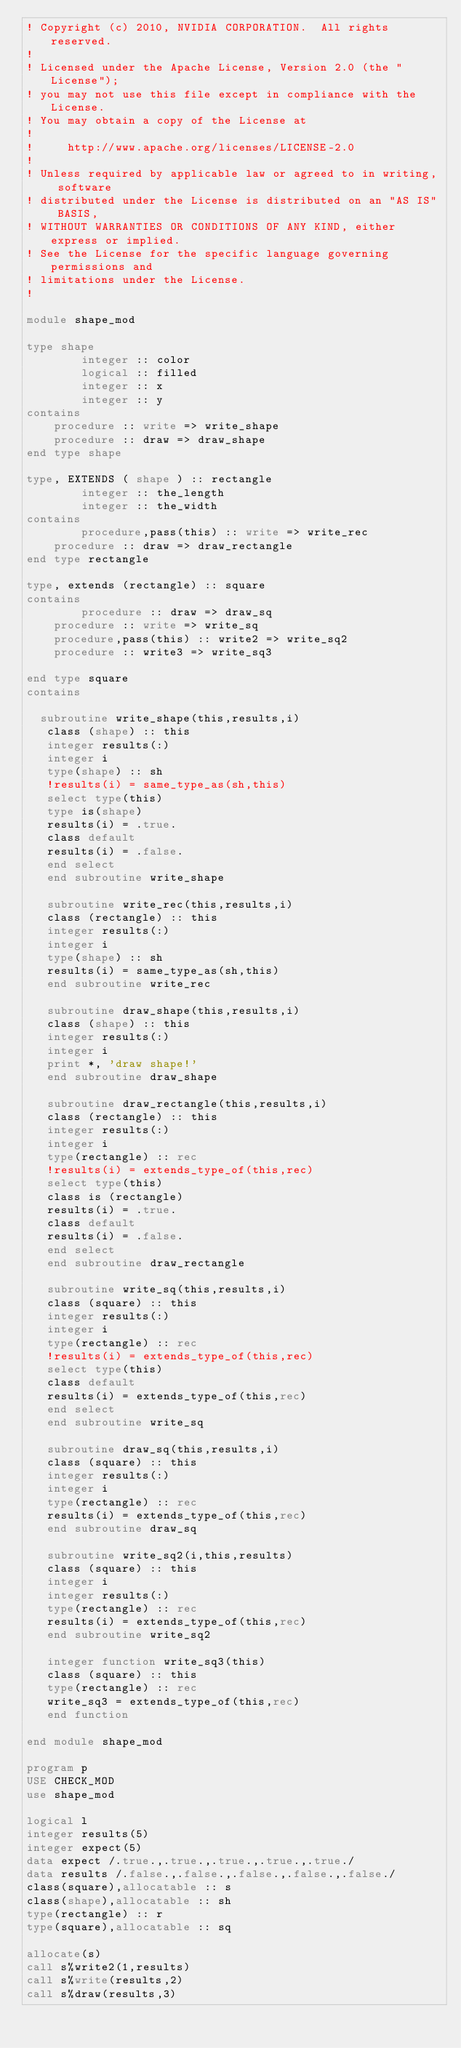<code> <loc_0><loc_0><loc_500><loc_500><_FORTRAN_>! Copyright (c) 2010, NVIDIA CORPORATION.  All rights reserved.
!
! Licensed under the Apache License, Version 2.0 (the "License");
! you may not use this file except in compliance with the License.
! You may obtain a copy of the License at
!
!     http://www.apache.org/licenses/LICENSE-2.0
!
! Unless required by applicable law or agreed to in writing, software
! distributed under the License is distributed on an "AS IS" BASIS,
! WITHOUT WARRANTIES OR CONDITIONS OF ANY KIND, either express or implied.
! See the License for the specific language governing permissions and
! limitations under the License.
!       

module shape_mod

type shape
        integer :: color
        logical :: filled
        integer :: x
        integer :: y
contains
	procedure :: write => write_shape 
	procedure :: draw => draw_shape
end type shape

type, EXTENDS ( shape ) :: rectangle
        integer :: the_length
        integer :: the_width
contains
        procedure,pass(this) :: write => write_rec
	procedure :: draw => draw_rectangle
end type rectangle

type, extends (rectangle) :: square
contains
        procedure :: draw => draw_sq
	procedure :: write => write_sq
	procedure,pass(this) :: write2 => write_sq2
	procedure :: write3 => write_sq3

end type square
contains

  subroutine write_shape(this,results,i)
   class (shape) :: this
   integer results(:)
   integer i
   type(shape) :: sh
   !results(i) = same_type_as(sh,this)
   select type(this)
   type is(shape)
   results(i) = .true.
   class default
   results(i) = .false.
   end select
   end subroutine write_shape

   subroutine write_rec(this,results,i)
   class (rectangle) :: this
   integer results(:)
   integer i
   type(shape) :: sh
   results(i) = same_type_as(sh,this)
   end subroutine write_rec

   subroutine draw_shape(this,results,i)
   class (shape) :: this
   integer results(:)
   integer i
   print *, 'draw shape!'
   end subroutine draw_shape

   subroutine draw_rectangle(this,results,i)
   class (rectangle) :: this
   integer results(:)
   integer i
   type(rectangle) :: rec
   !results(i) = extends_type_of(this,rec)
   select type(this)
   class is (rectangle)
   results(i) = .true.
   class default
   results(i) = .false.
   end select
   end subroutine draw_rectangle

   subroutine write_sq(this,results,i)
   class (square) :: this
   integer results(:)
   integer i
   type(rectangle) :: rec
   !results(i) = extends_type_of(this,rec)
   select type(this)
   class default
   results(i) = extends_type_of(this,rec)
   end select
   end subroutine write_sq

   subroutine draw_sq(this,results,i)
   class (square) :: this
   integer results(:)
   integer i
   type(rectangle) :: rec
   results(i) = extends_type_of(this,rec)
   end subroutine draw_sq

   subroutine write_sq2(i,this,results)
   class (square) :: this
   integer i 
   integer results(:)
   type(rectangle) :: rec
   results(i) = extends_type_of(this,rec)
   end subroutine write_sq2

   integer function write_sq3(this)
   class (square) :: this
   type(rectangle) :: rec
   write_sq3 = extends_type_of(this,rec)
   end function 

end module shape_mod

program p
USE CHECK_MOD
use shape_mod

logical l 
integer results(5)
integer expect(5)
data expect /.true.,.true.,.true.,.true.,.true./
data results /.false.,.false.,.false.,.false.,.false./
class(square),allocatable :: s
class(shape),allocatable :: sh
type(rectangle) :: r
type(square),allocatable :: sq

allocate(s)
call s%write2(1,results)
call s%write(results,2)
call s%draw(results,3)
</code> 